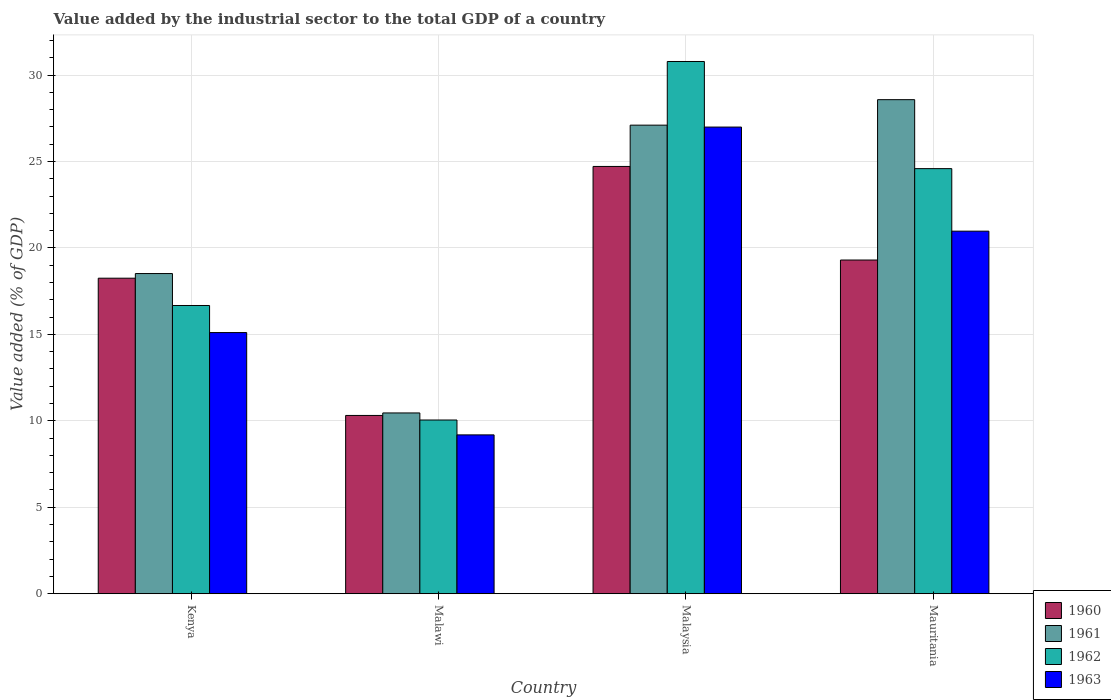How many different coloured bars are there?
Your answer should be compact. 4. How many groups of bars are there?
Provide a succinct answer. 4. Are the number of bars on each tick of the X-axis equal?
Keep it short and to the point. Yes. How many bars are there on the 1st tick from the left?
Give a very brief answer. 4. How many bars are there on the 2nd tick from the right?
Ensure brevity in your answer.  4. What is the label of the 3rd group of bars from the left?
Give a very brief answer. Malaysia. What is the value added by the industrial sector to the total GDP in 1963 in Mauritania?
Ensure brevity in your answer.  20.97. Across all countries, what is the maximum value added by the industrial sector to the total GDP in 1962?
Provide a short and direct response. 30.78. Across all countries, what is the minimum value added by the industrial sector to the total GDP in 1963?
Your response must be concise. 9.19. In which country was the value added by the industrial sector to the total GDP in 1961 maximum?
Make the answer very short. Mauritania. In which country was the value added by the industrial sector to the total GDP in 1961 minimum?
Offer a very short reply. Malawi. What is the total value added by the industrial sector to the total GDP in 1961 in the graph?
Your answer should be very brief. 84.65. What is the difference between the value added by the industrial sector to the total GDP in 1962 in Kenya and that in Mauritania?
Offer a very short reply. -7.92. What is the difference between the value added by the industrial sector to the total GDP in 1960 in Kenya and the value added by the industrial sector to the total GDP in 1962 in Malaysia?
Ensure brevity in your answer.  -12.53. What is the average value added by the industrial sector to the total GDP in 1963 per country?
Make the answer very short. 18.06. What is the difference between the value added by the industrial sector to the total GDP of/in 1962 and value added by the industrial sector to the total GDP of/in 1963 in Malaysia?
Your answer should be very brief. 3.79. What is the ratio of the value added by the industrial sector to the total GDP in 1962 in Kenya to that in Mauritania?
Your answer should be very brief. 0.68. Is the value added by the industrial sector to the total GDP in 1960 in Kenya less than that in Malaysia?
Offer a terse response. Yes. Is the difference between the value added by the industrial sector to the total GDP in 1962 in Kenya and Mauritania greater than the difference between the value added by the industrial sector to the total GDP in 1963 in Kenya and Mauritania?
Offer a very short reply. No. What is the difference between the highest and the second highest value added by the industrial sector to the total GDP in 1963?
Offer a terse response. 6.02. What is the difference between the highest and the lowest value added by the industrial sector to the total GDP in 1962?
Keep it short and to the point. 20.73. In how many countries, is the value added by the industrial sector to the total GDP in 1962 greater than the average value added by the industrial sector to the total GDP in 1962 taken over all countries?
Ensure brevity in your answer.  2. Is the sum of the value added by the industrial sector to the total GDP in 1963 in Kenya and Malawi greater than the maximum value added by the industrial sector to the total GDP in 1962 across all countries?
Offer a very short reply. No. What does the 2nd bar from the right in Malaysia represents?
Offer a terse response. 1962. Does the graph contain any zero values?
Your response must be concise. No. How many legend labels are there?
Give a very brief answer. 4. How are the legend labels stacked?
Your response must be concise. Vertical. What is the title of the graph?
Provide a succinct answer. Value added by the industrial sector to the total GDP of a country. What is the label or title of the X-axis?
Give a very brief answer. Country. What is the label or title of the Y-axis?
Your answer should be compact. Value added (% of GDP). What is the Value added (% of GDP) in 1960 in Kenya?
Offer a terse response. 18.25. What is the Value added (% of GDP) in 1961 in Kenya?
Make the answer very short. 18.52. What is the Value added (% of GDP) of 1962 in Kenya?
Make the answer very short. 16.67. What is the Value added (% of GDP) in 1963 in Kenya?
Your response must be concise. 15.1. What is the Value added (% of GDP) in 1960 in Malawi?
Provide a succinct answer. 10.31. What is the Value added (% of GDP) of 1961 in Malawi?
Provide a succinct answer. 10.46. What is the Value added (% of GDP) of 1962 in Malawi?
Make the answer very short. 10.05. What is the Value added (% of GDP) in 1963 in Malawi?
Keep it short and to the point. 9.19. What is the Value added (% of GDP) of 1960 in Malaysia?
Ensure brevity in your answer.  24.71. What is the Value added (% of GDP) in 1961 in Malaysia?
Provide a succinct answer. 27.1. What is the Value added (% of GDP) in 1962 in Malaysia?
Keep it short and to the point. 30.78. What is the Value added (% of GDP) of 1963 in Malaysia?
Your response must be concise. 26.99. What is the Value added (% of GDP) in 1960 in Mauritania?
Give a very brief answer. 19.3. What is the Value added (% of GDP) in 1961 in Mauritania?
Your answer should be very brief. 28.57. What is the Value added (% of GDP) of 1962 in Mauritania?
Your answer should be compact. 24.59. What is the Value added (% of GDP) in 1963 in Mauritania?
Give a very brief answer. 20.97. Across all countries, what is the maximum Value added (% of GDP) in 1960?
Offer a very short reply. 24.71. Across all countries, what is the maximum Value added (% of GDP) of 1961?
Provide a succinct answer. 28.57. Across all countries, what is the maximum Value added (% of GDP) of 1962?
Offer a very short reply. 30.78. Across all countries, what is the maximum Value added (% of GDP) in 1963?
Offer a very short reply. 26.99. Across all countries, what is the minimum Value added (% of GDP) in 1960?
Your response must be concise. 10.31. Across all countries, what is the minimum Value added (% of GDP) in 1961?
Provide a succinct answer. 10.46. Across all countries, what is the minimum Value added (% of GDP) of 1962?
Your response must be concise. 10.05. Across all countries, what is the minimum Value added (% of GDP) of 1963?
Your answer should be very brief. 9.19. What is the total Value added (% of GDP) in 1960 in the graph?
Provide a succinct answer. 72.57. What is the total Value added (% of GDP) in 1961 in the graph?
Your response must be concise. 84.65. What is the total Value added (% of GDP) of 1962 in the graph?
Make the answer very short. 82.08. What is the total Value added (% of GDP) of 1963 in the graph?
Your answer should be very brief. 72.25. What is the difference between the Value added (% of GDP) of 1960 in Kenya and that in Malawi?
Provide a short and direct response. 7.94. What is the difference between the Value added (% of GDP) in 1961 in Kenya and that in Malawi?
Your answer should be compact. 8.06. What is the difference between the Value added (% of GDP) in 1962 in Kenya and that in Malawi?
Keep it short and to the point. 6.62. What is the difference between the Value added (% of GDP) of 1963 in Kenya and that in Malawi?
Provide a succinct answer. 5.92. What is the difference between the Value added (% of GDP) of 1960 in Kenya and that in Malaysia?
Provide a short and direct response. -6.46. What is the difference between the Value added (% of GDP) of 1961 in Kenya and that in Malaysia?
Offer a terse response. -8.58. What is the difference between the Value added (% of GDP) of 1962 in Kenya and that in Malaysia?
Offer a very short reply. -14.11. What is the difference between the Value added (% of GDP) of 1963 in Kenya and that in Malaysia?
Your answer should be very brief. -11.88. What is the difference between the Value added (% of GDP) in 1960 in Kenya and that in Mauritania?
Keep it short and to the point. -1.05. What is the difference between the Value added (% of GDP) in 1961 in Kenya and that in Mauritania?
Ensure brevity in your answer.  -10.06. What is the difference between the Value added (% of GDP) of 1962 in Kenya and that in Mauritania?
Keep it short and to the point. -7.92. What is the difference between the Value added (% of GDP) of 1963 in Kenya and that in Mauritania?
Make the answer very short. -5.87. What is the difference between the Value added (% of GDP) of 1960 in Malawi and that in Malaysia?
Keep it short and to the point. -14.4. What is the difference between the Value added (% of GDP) in 1961 in Malawi and that in Malaysia?
Make the answer very short. -16.64. What is the difference between the Value added (% of GDP) of 1962 in Malawi and that in Malaysia?
Ensure brevity in your answer.  -20.73. What is the difference between the Value added (% of GDP) of 1963 in Malawi and that in Malaysia?
Ensure brevity in your answer.  -17.8. What is the difference between the Value added (% of GDP) of 1960 in Malawi and that in Mauritania?
Provide a short and direct response. -8.99. What is the difference between the Value added (% of GDP) in 1961 in Malawi and that in Mauritania?
Offer a terse response. -18.12. What is the difference between the Value added (% of GDP) of 1962 in Malawi and that in Mauritania?
Provide a succinct answer. -14.54. What is the difference between the Value added (% of GDP) in 1963 in Malawi and that in Mauritania?
Your response must be concise. -11.78. What is the difference between the Value added (% of GDP) of 1960 in Malaysia and that in Mauritania?
Provide a succinct answer. 5.41. What is the difference between the Value added (% of GDP) of 1961 in Malaysia and that in Mauritania?
Offer a very short reply. -1.47. What is the difference between the Value added (% of GDP) of 1962 in Malaysia and that in Mauritania?
Provide a succinct answer. 6.2. What is the difference between the Value added (% of GDP) of 1963 in Malaysia and that in Mauritania?
Provide a succinct answer. 6.02. What is the difference between the Value added (% of GDP) of 1960 in Kenya and the Value added (% of GDP) of 1961 in Malawi?
Offer a very short reply. 7.79. What is the difference between the Value added (% of GDP) of 1960 in Kenya and the Value added (% of GDP) of 1962 in Malawi?
Offer a very short reply. 8.2. What is the difference between the Value added (% of GDP) of 1960 in Kenya and the Value added (% of GDP) of 1963 in Malawi?
Keep it short and to the point. 9.06. What is the difference between the Value added (% of GDP) in 1961 in Kenya and the Value added (% of GDP) in 1962 in Malawi?
Your answer should be compact. 8.47. What is the difference between the Value added (% of GDP) in 1961 in Kenya and the Value added (% of GDP) in 1963 in Malawi?
Provide a short and direct response. 9.33. What is the difference between the Value added (% of GDP) of 1962 in Kenya and the Value added (% of GDP) of 1963 in Malawi?
Provide a succinct answer. 7.48. What is the difference between the Value added (% of GDP) in 1960 in Kenya and the Value added (% of GDP) in 1961 in Malaysia?
Provide a short and direct response. -8.85. What is the difference between the Value added (% of GDP) in 1960 in Kenya and the Value added (% of GDP) in 1962 in Malaysia?
Ensure brevity in your answer.  -12.53. What is the difference between the Value added (% of GDP) of 1960 in Kenya and the Value added (% of GDP) of 1963 in Malaysia?
Make the answer very short. -8.74. What is the difference between the Value added (% of GDP) of 1961 in Kenya and the Value added (% of GDP) of 1962 in Malaysia?
Offer a terse response. -12.26. What is the difference between the Value added (% of GDP) in 1961 in Kenya and the Value added (% of GDP) in 1963 in Malaysia?
Offer a terse response. -8.47. What is the difference between the Value added (% of GDP) of 1962 in Kenya and the Value added (% of GDP) of 1963 in Malaysia?
Ensure brevity in your answer.  -10.32. What is the difference between the Value added (% of GDP) of 1960 in Kenya and the Value added (% of GDP) of 1961 in Mauritania?
Provide a succinct answer. -10.33. What is the difference between the Value added (% of GDP) in 1960 in Kenya and the Value added (% of GDP) in 1962 in Mauritania?
Keep it short and to the point. -6.34. What is the difference between the Value added (% of GDP) in 1960 in Kenya and the Value added (% of GDP) in 1963 in Mauritania?
Your answer should be compact. -2.72. What is the difference between the Value added (% of GDP) of 1961 in Kenya and the Value added (% of GDP) of 1962 in Mauritania?
Make the answer very short. -6.07. What is the difference between the Value added (% of GDP) in 1961 in Kenya and the Value added (% of GDP) in 1963 in Mauritania?
Offer a very short reply. -2.45. What is the difference between the Value added (% of GDP) in 1962 in Kenya and the Value added (% of GDP) in 1963 in Mauritania?
Keep it short and to the point. -4.3. What is the difference between the Value added (% of GDP) of 1960 in Malawi and the Value added (% of GDP) of 1961 in Malaysia?
Offer a very short reply. -16.79. What is the difference between the Value added (% of GDP) in 1960 in Malawi and the Value added (% of GDP) in 1962 in Malaysia?
Your answer should be compact. -20.47. What is the difference between the Value added (% of GDP) of 1960 in Malawi and the Value added (% of GDP) of 1963 in Malaysia?
Provide a short and direct response. -16.68. What is the difference between the Value added (% of GDP) in 1961 in Malawi and the Value added (% of GDP) in 1962 in Malaysia?
Give a very brief answer. -20.33. What is the difference between the Value added (% of GDP) in 1961 in Malawi and the Value added (% of GDP) in 1963 in Malaysia?
Your answer should be very brief. -16.53. What is the difference between the Value added (% of GDP) of 1962 in Malawi and the Value added (% of GDP) of 1963 in Malaysia?
Keep it short and to the point. -16.94. What is the difference between the Value added (% of GDP) of 1960 in Malawi and the Value added (% of GDP) of 1961 in Mauritania?
Give a very brief answer. -18.26. What is the difference between the Value added (% of GDP) of 1960 in Malawi and the Value added (% of GDP) of 1962 in Mauritania?
Ensure brevity in your answer.  -14.27. What is the difference between the Value added (% of GDP) in 1960 in Malawi and the Value added (% of GDP) in 1963 in Mauritania?
Provide a short and direct response. -10.66. What is the difference between the Value added (% of GDP) in 1961 in Malawi and the Value added (% of GDP) in 1962 in Mauritania?
Give a very brief answer. -14.13. What is the difference between the Value added (% of GDP) of 1961 in Malawi and the Value added (% of GDP) of 1963 in Mauritania?
Provide a succinct answer. -10.51. What is the difference between the Value added (% of GDP) in 1962 in Malawi and the Value added (% of GDP) in 1963 in Mauritania?
Your response must be concise. -10.92. What is the difference between the Value added (% of GDP) of 1960 in Malaysia and the Value added (% of GDP) of 1961 in Mauritania?
Offer a terse response. -3.86. What is the difference between the Value added (% of GDP) of 1960 in Malaysia and the Value added (% of GDP) of 1962 in Mauritania?
Offer a terse response. 0.13. What is the difference between the Value added (% of GDP) in 1960 in Malaysia and the Value added (% of GDP) in 1963 in Mauritania?
Your answer should be very brief. 3.74. What is the difference between the Value added (% of GDP) of 1961 in Malaysia and the Value added (% of GDP) of 1962 in Mauritania?
Provide a succinct answer. 2.51. What is the difference between the Value added (% of GDP) in 1961 in Malaysia and the Value added (% of GDP) in 1963 in Mauritania?
Give a very brief answer. 6.13. What is the difference between the Value added (% of GDP) of 1962 in Malaysia and the Value added (% of GDP) of 1963 in Mauritania?
Ensure brevity in your answer.  9.81. What is the average Value added (% of GDP) in 1960 per country?
Your answer should be very brief. 18.14. What is the average Value added (% of GDP) in 1961 per country?
Provide a succinct answer. 21.16. What is the average Value added (% of GDP) in 1962 per country?
Your answer should be compact. 20.52. What is the average Value added (% of GDP) of 1963 per country?
Your answer should be very brief. 18.06. What is the difference between the Value added (% of GDP) of 1960 and Value added (% of GDP) of 1961 in Kenya?
Your answer should be compact. -0.27. What is the difference between the Value added (% of GDP) of 1960 and Value added (% of GDP) of 1962 in Kenya?
Offer a very short reply. 1.58. What is the difference between the Value added (% of GDP) of 1960 and Value added (% of GDP) of 1963 in Kenya?
Your answer should be compact. 3.14. What is the difference between the Value added (% of GDP) in 1961 and Value added (% of GDP) in 1962 in Kenya?
Your answer should be compact. 1.85. What is the difference between the Value added (% of GDP) of 1961 and Value added (% of GDP) of 1963 in Kenya?
Offer a very short reply. 3.41. What is the difference between the Value added (% of GDP) of 1962 and Value added (% of GDP) of 1963 in Kenya?
Offer a terse response. 1.57. What is the difference between the Value added (% of GDP) in 1960 and Value added (% of GDP) in 1961 in Malawi?
Give a very brief answer. -0.15. What is the difference between the Value added (% of GDP) in 1960 and Value added (% of GDP) in 1962 in Malawi?
Your answer should be compact. 0.26. What is the difference between the Value added (% of GDP) in 1960 and Value added (% of GDP) in 1963 in Malawi?
Your answer should be very brief. 1.12. What is the difference between the Value added (% of GDP) in 1961 and Value added (% of GDP) in 1962 in Malawi?
Your response must be concise. 0.41. What is the difference between the Value added (% of GDP) in 1961 and Value added (% of GDP) in 1963 in Malawi?
Ensure brevity in your answer.  1.27. What is the difference between the Value added (% of GDP) of 1962 and Value added (% of GDP) of 1963 in Malawi?
Ensure brevity in your answer.  0.86. What is the difference between the Value added (% of GDP) in 1960 and Value added (% of GDP) in 1961 in Malaysia?
Provide a short and direct response. -2.39. What is the difference between the Value added (% of GDP) of 1960 and Value added (% of GDP) of 1962 in Malaysia?
Your response must be concise. -6.07. What is the difference between the Value added (% of GDP) of 1960 and Value added (% of GDP) of 1963 in Malaysia?
Provide a short and direct response. -2.28. What is the difference between the Value added (% of GDP) in 1961 and Value added (% of GDP) in 1962 in Malaysia?
Ensure brevity in your answer.  -3.68. What is the difference between the Value added (% of GDP) of 1961 and Value added (% of GDP) of 1963 in Malaysia?
Make the answer very short. 0.11. What is the difference between the Value added (% of GDP) of 1962 and Value added (% of GDP) of 1963 in Malaysia?
Offer a very short reply. 3.79. What is the difference between the Value added (% of GDP) in 1960 and Value added (% of GDP) in 1961 in Mauritania?
Provide a short and direct response. -9.27. What is the difference between the Value added (% of GDP) in 1960 and Value added (% of GDP) in 1962 in Mauritania?
Make the answer very short. -5.29. What is the difference between the Value added (% of GDP) of 1960 and Value added (% of GDP) of 1963 in Mauritania?
Provide a succinct answer. -1.67. What is the difference between the Value added (% of GDP) in 1961 and Value added (% of GDP) in 1962 in Mauritania?
Keep it short and to the point. 3.99. What is the difference between the Value added (% of GDP) of 1961 and Value added (% of GDP) of 1963 in Mauritania?
Give a very brief answer. 7.6. What is the difference between the Value added (% of GDP) of 1962 and Value added (% of GDP) of 1963 in Mauritania?
Offer a terse response. 3.62. What is the ratio of the Value added (% of GDP) in 1960 in Kenya to that in Malawi?
Your response must be concise. 1.77. What is the ratio of the Value added (% of GDP) of 1961 in Kenya to that in Malawi?
Offer a very short reply. 1.77. What is the ratio of the Value added (% of GDP) in 1962 in Kenya to that in Malawi?
Your answer should be very brief. 1.66. What is the ratio of the Value added (% of GDP) of 1963 in Kenya to that in Malawi?
Your response must be concise. 1.64. What is the ratio of the Value added (% of GDP) in 1960 in Kenya to that in Malaysia?
Your response must be concise. 0.74. What is the ratio of the Value added (% of GDP) in 1961 in Kenya to that in Malaysia?
Give a very brief answer. 0.68. What is the ratio of the Value added (% of GDP) of 1962 in Kenya to that in Malaysia?
Offer a very short reply. 0.54. What is the ratio of the Value added (% of GDP) in 1963 in Kenya to that in Malaysia?
Offer a very short reply. 0.56. What is the ratio of the Value added (% of GDP) of 1960 in Kenya to that in Mauritania?
Your response must be concise. 0.95. What is the ratio of the Value added (% of GDP) in 1961 in Kenya to that in Mauritania?
Your answer should be compact. 0.65. What is the ratio of the Value added (% of GDP) of 1962 in Kenya to that in Mauritania?
Give a very brief answer. 0.68. What is the ratio of the Value added (% of GDP) in 1963 in Kenya to that in Mauritania?
Provide a succinct answer. 0.72. What is the ratio of the Value added (% of GDP) of 1960 in Malawi to that in Malaysia?
Your response must be concise. 0.42. What is the ratio of the Value added (% of GDP) in 1961 in Malawi to that in Malaysia?
Make the answer very short. 0.39. What is the ratio of the Value added (% of GDP) of 1962 in Malawi to that in Malaysia?
Your answer should be compact. 0.33. What is the ratio of the Value added (% of GDP) in 1963 in Malawi to that in Malaysia?
Provide a short and direct response. 0.34. What is the ratio of the Value added (% of GDP) of 1960 in Malawi to that in Mauritania?
Offer a very short reply. 0.53. What is the ratio of the Value added (% of GDP) of 1961 in Malawi to that in Mauritania?
Offer a very short reply. 0.37. What is the ratio of the Value added (% of GDP) in 1962 in Malawi to that in Mauritania?
Make the answer very short. 0.41. What is the ratio of the Value added (% of GDP) of 1963 in Malawi to that in Mauritania?
Provide a short and direct response. 0.44. What is the ratio of the Value added (% of GDP) in 1960 in Malaysia to that in Mauritania?
Offer a terse response. 1.28. What is the ratio of the Value added (% of GDP) of 1961 in Malaysia to that in Mauritania?
Keep it short and to the point. 0.95. What is the ratio of the Value added (% of GDP) of 1962 in Malaysia to that in Mauritania?
Your answer should be compact. 1.25. What is the ratio of the Value added (% of GDP) of 1963 in Malaysia to that in Mauritania?
Your answer should be compact. 1.29. What is the difference between the highest and the second highest Value added (% of GDP) of 1960?
Offer a very short reply. 5.41. What is the difference between the highest and the second highest Value added (% of GDP) of 1961?
Your answer should be compact. 1.47. What is the difference between the highest and the second highest Value added (% of GDP) in 1962?
Your answer should be compact. 6.2. What is the difference between the highest and the second highest Value added (% of GDP) in 1963?
Ensure brevity in your answer.  6.02. What is the difference between the highest and the lowest Value added (% of GDP) in 1960?
Keep it short and to the point. 14.4. What is the difference between the highest and the lowest Value added (% of GDP) in 1961?
Your response must be concise. 18.12. What is the difference between the highest and the lowest Value added (% of GDP) in 1962?
Give a very brief answer. 20.73. What is the difference between the highest and the lowest Value added (% of GDP) in 1963?
Ensure brevity in your answer.  17.8. 